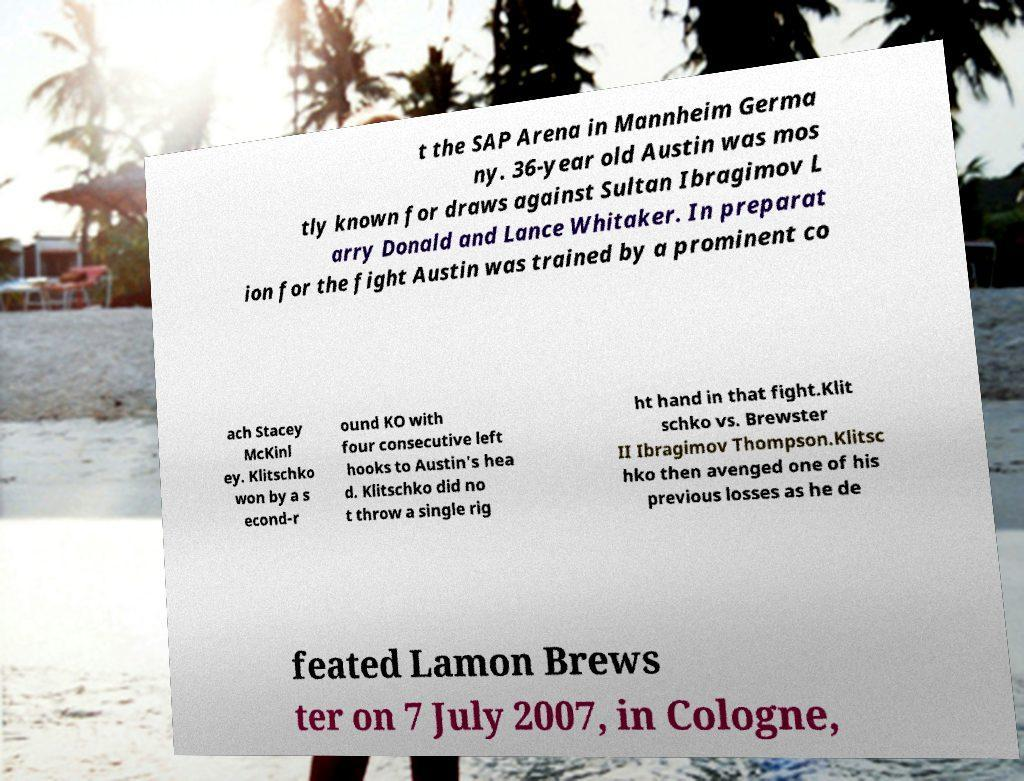Could you extract and type out the text from this image? t the SAP Arena in Mannheim Germa ny. 36-year old Austin was mos tly known for draws against Sultan Ibragimov L arry Donald and Lance Whitaker. In preparat ion for the fight Austin was trained by a prominent co ach Stacey McKinl ey. Klitschko won by a s econd-r ound KO with four consecutive left hooks to Austin's hea d. Klitschko did no t throw a single rig ht hand in that fight.Klit schko vs. Brewster II Ibragimov Thompson.Klitsc hko then avenged one of his previous losses as he de feated Lamon Brews ter on 7 July 2007, in Cologne, 